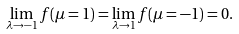<formula> <loc_0><loc_0><loc_500><loc_500>\lim _ { \lambda \rightarrow - 1 } f ( \mu = 1 ) = \lim _ { \lambda \rightarrow 1 } f ( \mu = - 1 ) = 0 .</formula> 